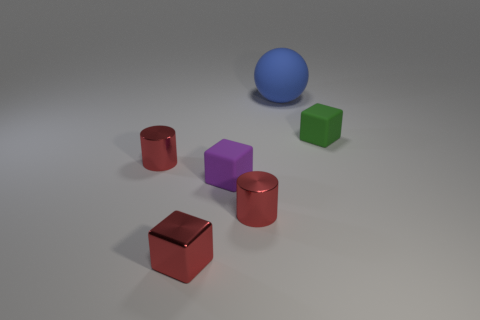How many things are either metal things to the right of the small purple matte thing or small cubes on the left side of the green matte block?
Provide a short and direct response. 3. What number of small objects are both right of the purple matte thing and on the left side of the green object?
Provide a short and direct response. 1. Are the big blue object and the red block made of the same material?
Your answer should be very brief. No. There is a small red shiny object that is behind the matte thing in front of the tiny block to the right of the ball; what shape is it?
Ensure brevity in your answer.  Cylinder. The thing that is both behind the shiny cube and left of the small purple matte thing is made of what material?
Provide a succinct answer. Metal. There is a cube behind the matte block in front of the tiny metallic thing behind the purple object; what color is it?
Make the answer very short. Green. How many purple things are metal cylinders or rubber blocks?
Keep it short and to the point. 1. What number of other things are the same size as the purple object?
Ensure brevity in your answer.  4. What number of small shiny objects are there?
Keep it short and to the point. 3. Are there any other things that are the same shape as the green matte object?
Keep it short and to the point. Yes. 